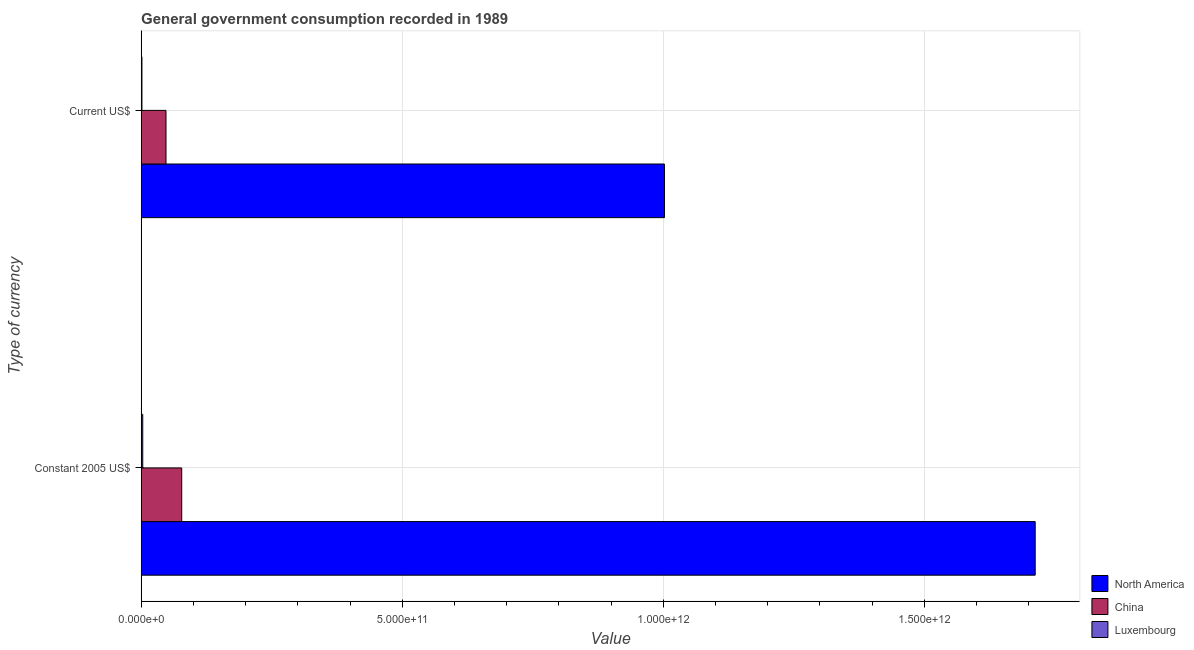How many different coloured bars are there?
Provide a short and direct response. 3. How many groups of bars are there?
Give a very brief answer. 2. Are the number of bars per tick equal to the number of legend labels?
Keep it short and to the point. Yes. How many bars are there on the 2nd tick from the top?
Your answer should be compact. 3. What is the label of the 1st group of bars from the top?
Provide a succinct answer. Current US$. What is the value consumed in current us$ in North America?
Provide a succinct answer. 1.00e+12. Across all countries, what is the maximum value consumed in current us$?
Keep it short and to the point. 1.00e+12. Across all countries, what is the minimum value consumed in constant 2005 us$?
Provide a short and direct response. 3.06e+09. In which country was the value consumed in current us$ maximum?
Give a very brief answer. North America. In which country was the value consumed in current us$ minimum?
Your response must be concise. Luxembourg. What is the total value consumed in current us$ in the graph?
Your response must be concise. 1.05e+12. What is the difference between the value consumed in current us$ in China and that in Luxembourg?
Give a very brief answer. 4.61e+1. What is the difference between the value consumed in constant 2005 us$ in North America and the value consumed in current us$ in China?
Offer a terse response. 1.66e+12. What is the average value consumed in constant 2005 us$ per country?
Make the answer very short. 5.98e+11. What is the difference between the value consumed in constant 2005 us$ and value consumed in current us$ in China?
Offer a very short reply. 3.01e+1. In how many countries, is the value consumed in constant 2005 us$ greater than 1100000000000 ?
Offer a terse response. 1. What is the ratio of the value consumed in constant 2005 us$ in China to that in North America?
Provide a succinct answer. 0.05. Is the value consumed in constant 2005 us$ in China less than that in North America?
Your response must be concise. Yes. What does the 1st bar from the top in Constant 2005 US$ represents?
Offer a very short reply. Luxembourg. What does the 2nd bar from the bottom in Constant 2005 US$ represents?
Give a very brief answer. China. Are all the bars in the graph horizontal?
Ensure brevity in your answer.  Yes. How many countries are there in the graph?
Your response must be concise. 3. What is the difference between two consecutive major ticks on the X-axis?
Offer a terse response. 5.00e+11. Are the values on the major ticks of X-axis written in scientific E-notation?
Keep it short and to the point. Yes. Does the graph contain any zero values?
Offer a terse response. No. What is the title of the graph?
Provide a succinct answer. General government consumption recorded in 1989. Does "Botswana" appear as one of the legend labels in the graph?
Your answer should be very brief. No. What is the label or title of the X-axis?
Keep it short and to the point. Value. What is the label or title of the Y-axis?
Your answer should be very brief. Type of currency. What is the Value of North America in Constant 2005 US$?
Make the answer very short. 1.71e+12. What is the Value in China in Constant 2005 US$?
Offer a very short reply. 7.77e+1. What is the Value in Luxembourg in Constant 2005 US$?
Your response must be concise. 3.06e+09. What is the Value of North America in Current US$?
Provide a succinct answer. 1.00e+12. What is the Value in China in Current US$?
Your answer should be very brief. 4.76e+1. What is the Value of Luxembourg in Current US$?
Ensure brevity in your answer.  1.53e+09. Across all Type of currency, what is the maximum Value in North America?
Keep it short and to the point. 1.71e+12. Across all Type of currency, what is the maximum Value of China?
Keep it short and to the point. 7.77e+1. Across all Type of currency, what is the maximum Value of Luxembourg?
Provide a succinct answer. 3.06e+09. Across all Type of currency, what is the minimum Value of North America?
Provide a short and direct response. 1.00e+12. Across all Type of currency, what is the minimum Value in China?
Keep it short and to the point. 4.76e+1. Across all Type of currency, what is the minimum Value in Luxembourg?
Offer a terse response. 1.53e+09. What is the total Value in North America in the graph?
Ensure brevity in your answer.  2.71e+12. What is the total Value in China in the graph?
Keep it short and to the point. 1.25e+11. What is the total Value in Luxembourg in the graph?
Ensure brevity in your answer.  4.58e+09. What is the difference between the Value in North America in Constant 2005 US$ and that in Current US$?
Provide a short and direct response. 7.10e+11. What is the difference between the Value in China in Constant 2005 US$ and that in Current US$?
Offer a very short reply. 3.01e+1. What is the difference between the Value of Luxembourg in Constant 2005 US$ and that in Current US$?
Provide a succinct answer. 1.53e+09. What is the difference between the Value of North America in Constant 2005 US$ and the Value of China in Current US$?
Offer a very short reply. 1.66e+12. What is the difference between the Value in North America in Constant 2005 US$ and the Value in Luxembourg in Current US$?
Give a very brief answer. 1.71e+12. What is the difference between the Value of China in Constant 2005 US$ and the Value of Luxembourg in Current US$?
Provide a succinct answer. 7.62e+1. What is the average Value in North America per Type of currency?
Give a very brief answer. 1.36e+12. What is the average Value of China per Type of currency?
Make the answer very short. 6.26e+1. What is the average Value in Luxembourg per Type of currency?
Ensure brevity in your answer.  2.29e+09. What is the difference between the Value in North America and Value in China in Constant 2005 US$?
Give a very brief answer. 1.63e+12. What is the difference between the Value in North America and Value in Luxembourg in Constant 2005 US$?
Your answer should be very brief. 1.71e+12. What is the difference between the Value in China and Value in Luxembourg in Constant 2005 US$?
Your answer should be very brief. 7.46e+1. What is the difference between the Value of North America and Value of China in Current US$?
Provide a short and direct response. 9.55e+11. What is the difference between the Value of North America and Value of Luxembourg in Current US$?
Keep it short and to the point. 1.00e+12. What is the difference between the Value of China and Value of Luxembourg in Current US$?
Offer a very short reply. 4.61e+1. What is the ratio of the Value in North America in Constant 2005 US$ to that in Current US$?
Give a very brief answer. 1.71. What is the ratio of the Value of China in Constant 2005 US$ to that in Current US$?
Offer a terse response. 1.63. What is the ratio of the Value of Luxembourg in Constant 2005 US$ to that in Current US$?
Offer a terse response. 2. What is the difference between the highest and the second highest Value in North America?
Your response must be concise. 7.10e+11. What is the difference between the highest and the second highest Value in China?
Your answer should be compact. 3.01e+1. What is the difference between the highest and the second highest Value of Luxembourg?
Your answer should be very brief. 1.53e+09. What is the difference between the highest and the lowest Value of North America?
Your answer should be compact. 7.10e+11. What is the difference between the highest and the lowest Value in China?
Make the answer very short. 3.01e+1. What is the difference between the highest and the lowest Value in Luxembourg?
Give a very brief answer. 1.53e+09. 